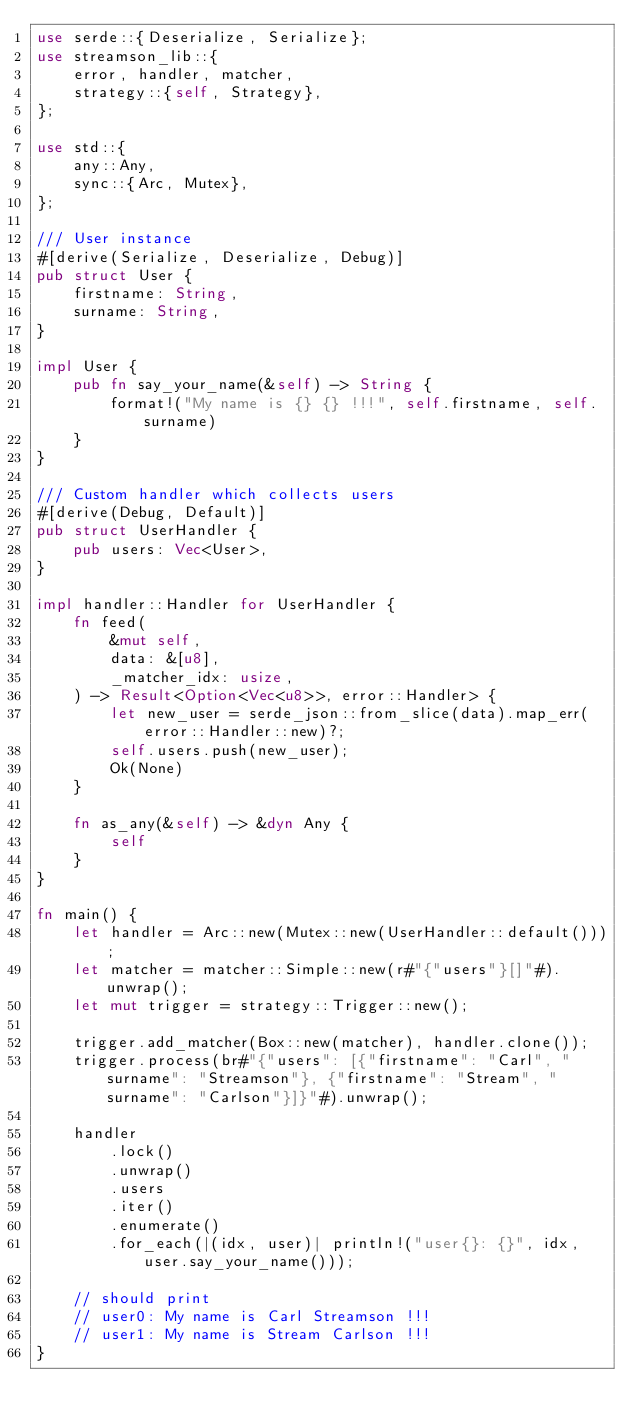Convert code to text. <code><loc_0><loc_0><loc_500><loc_500><_Rust_>use serde::{Deserialize, Serialize};
use streamson_lib::{
    error, handler, matcher,
    strategy::{self, Strategy},
};

use std::{
    any::Any,
    sync::{Arc, Mutex},
};

/// User instance
#[derive(Serialize, Deserialize, Debug)]
pub struct User {
    firstname: String,
    surname: String,
}

impl User {
    pub fn say_your_name(&self) -> String {
        format!("My name is {} {} !!!", self.firstname, self.surname)
    }
}

/// Custom handler which collects users
#[derive(Debug, Default)]
pub struct UserHandler {
    pub users: Vec<User>,
}

impl handler::Handler for UserHandler {
    fn feed(
        &mut self,
        data: &[u8],
        _matcher_idx: usize,
    ) -> Result<Option<Vec<u8>>, error::Handler> {
        let new_user = serde_json::from_slice(data).map_err(error::Handler::new)?;
        self.users.push(new_user);
        Ok(None)
    }

    fn as_any(&self) -> &dyn Any {
        self
    }
}

fn main() {
    let handler = Arc::new(Mutex::new(UserHandler::default()));
    let matcher = matcher::Simple::new(r#"{"users"}[]"#).unwrap();
    let mut trigger = strategy::Trigger::new();

    trigger.add_matcher(Box::new(matcher), handler.clone());
    trigger.process(br#"{"users": [{"firstname": "Carl", "surname": "Streamson"}, {"firstname": "Stream", "surname": "Carlson"}]}"#).unwrap();

    handler
        .lock()
        .unwrap()
        .users
        .iter()
        .enumerate()
        .for_each(|(idx, user)| println!("user{}: {}", idx, user.say_your_name()));

    // should print
    // user0: My name is Carl Streamson !!!
    // user1: My name is Stream Carlson !!!
}
</code> 